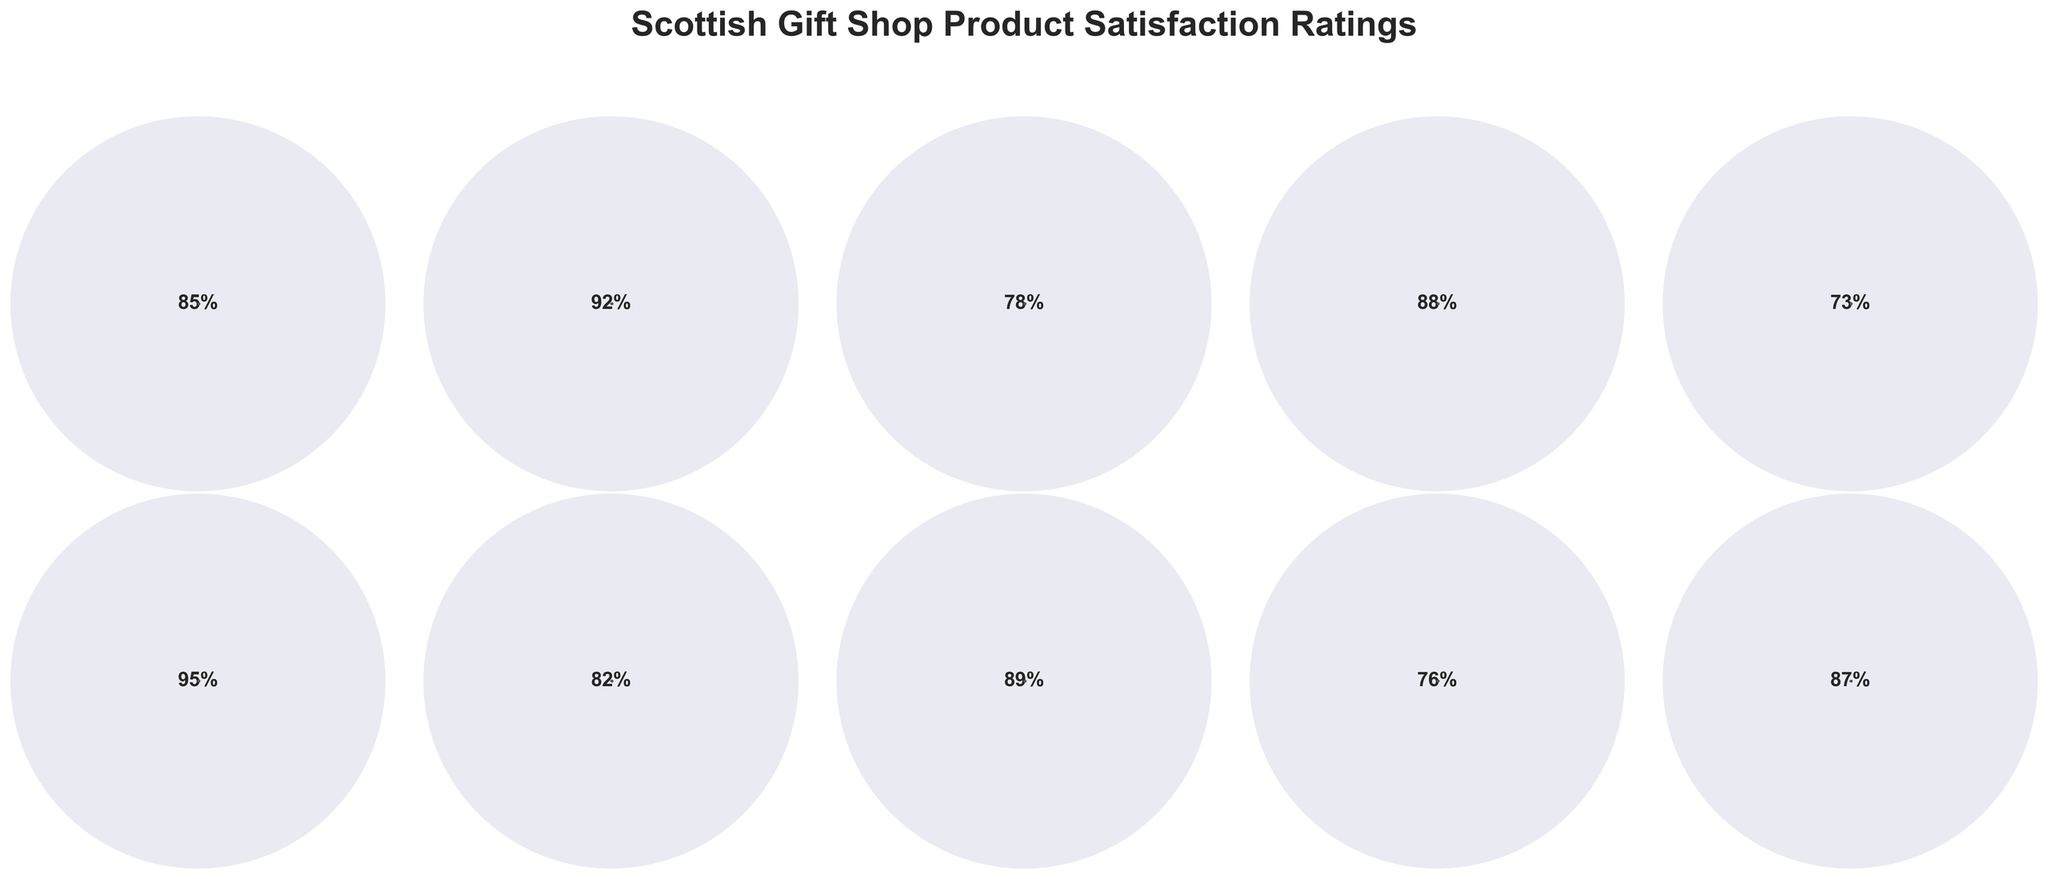What's the highest customer satisfaction rating in the figure? To find the highest satisfaction rating, one must compare the ratings for each product category. Bagpipe Ornaments have the highest rating at 95%.
Answer: 95% Which product category has the lowest satisfaction rating? By comparing the satisfaction ratings of all categories, Clan Crest Jewelry has the lowest rating at 73%.
Answer: Clan Crest Jewelry What is the average customer satisfaction rating for all product categories? Sum all the satisfaction ratings and divide by the number of categories. (85 + 92 + 78 + 88 + 73 + 95 + 82 + 89 + 76 + 87) / 10 = 84.5
Answer: 84.5 How many product categories have a satisfaction rating above 85%? Count the product categories with ratings higher than 85%. The categories are Shortbread Tins, Highland Cow Plush Toys, Bagpipe Ornaments, Scottish Landscape Prints, and Thistle-themed Homeware, making 5 in total.
Answer: 5 Which product categories have satisfaction ratings below 80%? Identify the categories with ratings less than 80%. The categories are Whisky Glasses, Clan Crest Jewelry, and Nessie Souvenirs.
Answer: Whisky Glasses, Clan Crest Jewelry, Nessie Souvenirs Are there more product categories with satisfaction ratings above 90% or below 80%? Compare the count of categories above 90% and below 80%. Above 90% there are two: Shortbread Tins and Bagpipe Ornaments. Below 80%, there are three: Whisky Glasses, Clan Crest Jewelry, Nessie Souvenirs.
Answer: Below 80% What is the median customer satisfaction rating for all product categories? Arrange the ratings in ascending order and find the middle value. (73, 76, 78, 82, 85, 87, 88, 89, 92, 95). The middle values are 85 and 87, so the median is (85 + 87)/2 = 86.
Answer: 86 Which product category has a satisfaction rating closest to 90%? Compare all ratings to 90% and find the closest one. Scottish Landscape Prints have a rating of 89%, which is the closest.
Answer: Scottish Landscape Prints What is the range of customer satisfaction ratings in the figure? Subtract the lowest rating from the highest rating. 95% (Bagpipe Ornaments) - 73% (Clan Crest Jewelry) = 22%.
Answer: 22 What percentage of product categories have a satisfaction rating between 80% and 90%? Calculate the number of categories in the range and divide by the total number. There are Tartan Scarves (85%), Highland Cow Plush Toys (88%), Kilt Accessories (82%), Scottish Landscape Prints (89%), Thistle-themed Homeware (87%). That's 5 out of 10 categories, giving 50%.
Answer: 50% 